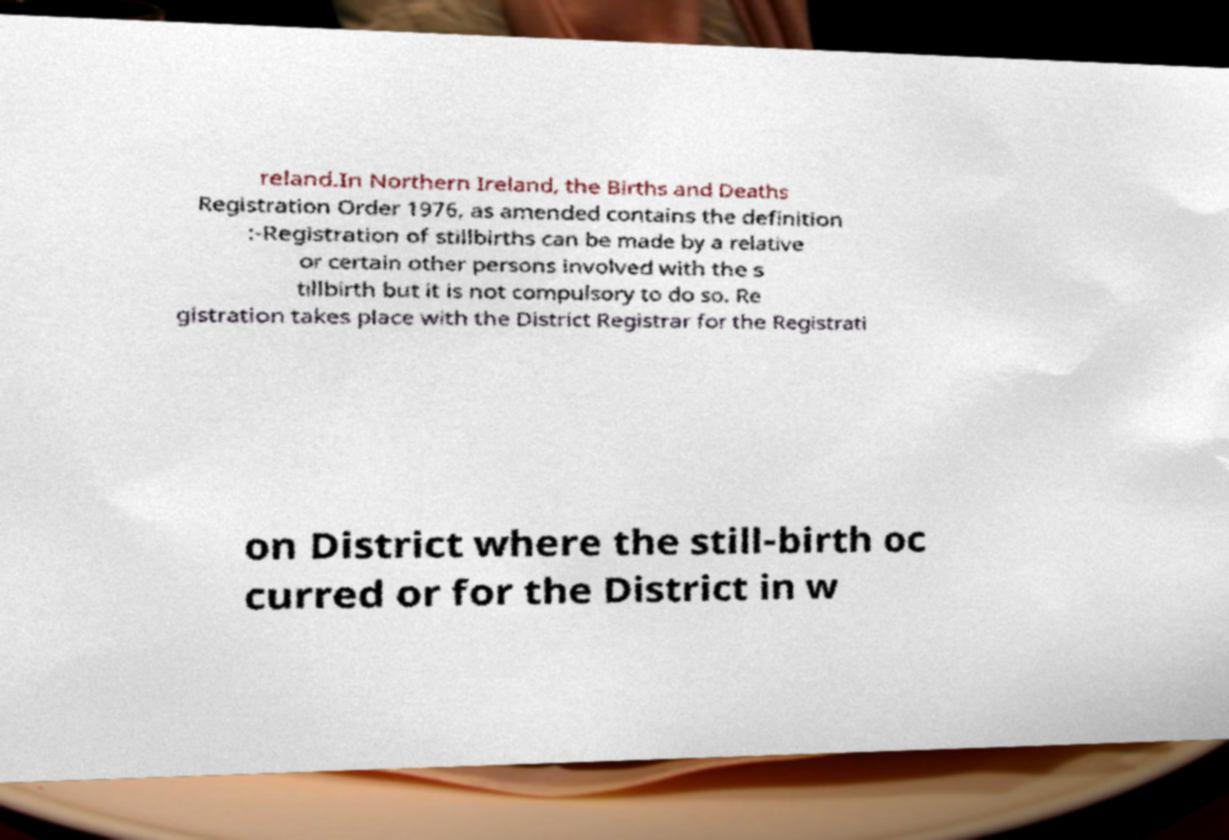Could you extract and type out the text from this image? reland.In Northern Ireland, the Births and Deaths Registration Order 1976, as amended contains the definition :-Registration of stillbirths can be made by a relative or certain other persons involved with the s tillbirth but it is not compulsory to do so. Re gistration takes place with the District Registrar for the Registrati on District where the still-birth oc curred or for the District in w 